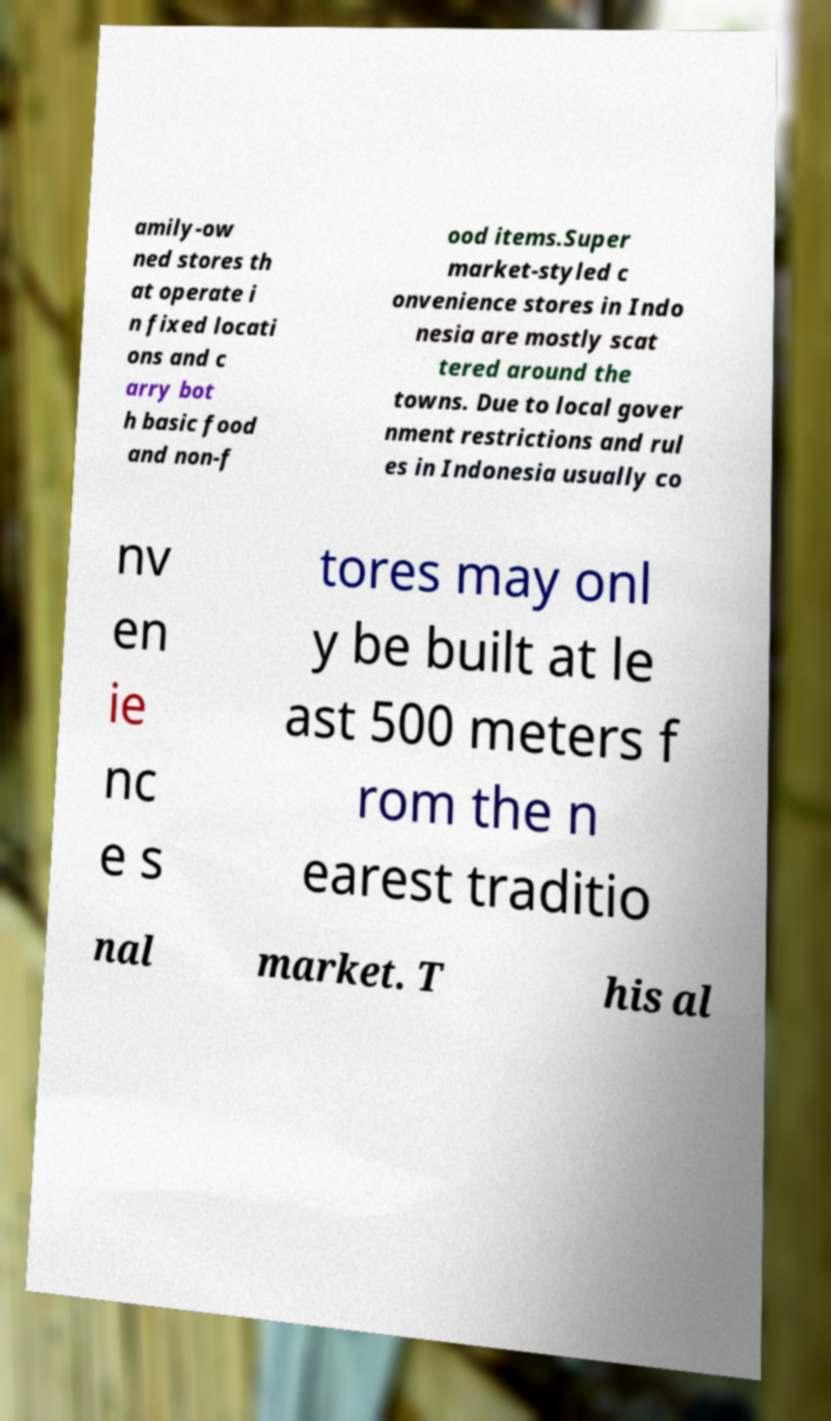Could you extract and type out the text from this image? amily-ow ned stores th at operate i n fixed locati ons and c arry bot h basic food and non-f ood items.Super market-styled c onvenience stores in Indo nesia are mostly scat tered around the towns. Due to local gover nment restrictions and rul es in Indonesia usually co nv en ie nc e s tores may onl y be built at le ast 500 meters f rom the n earest traditio nal market. T his al 